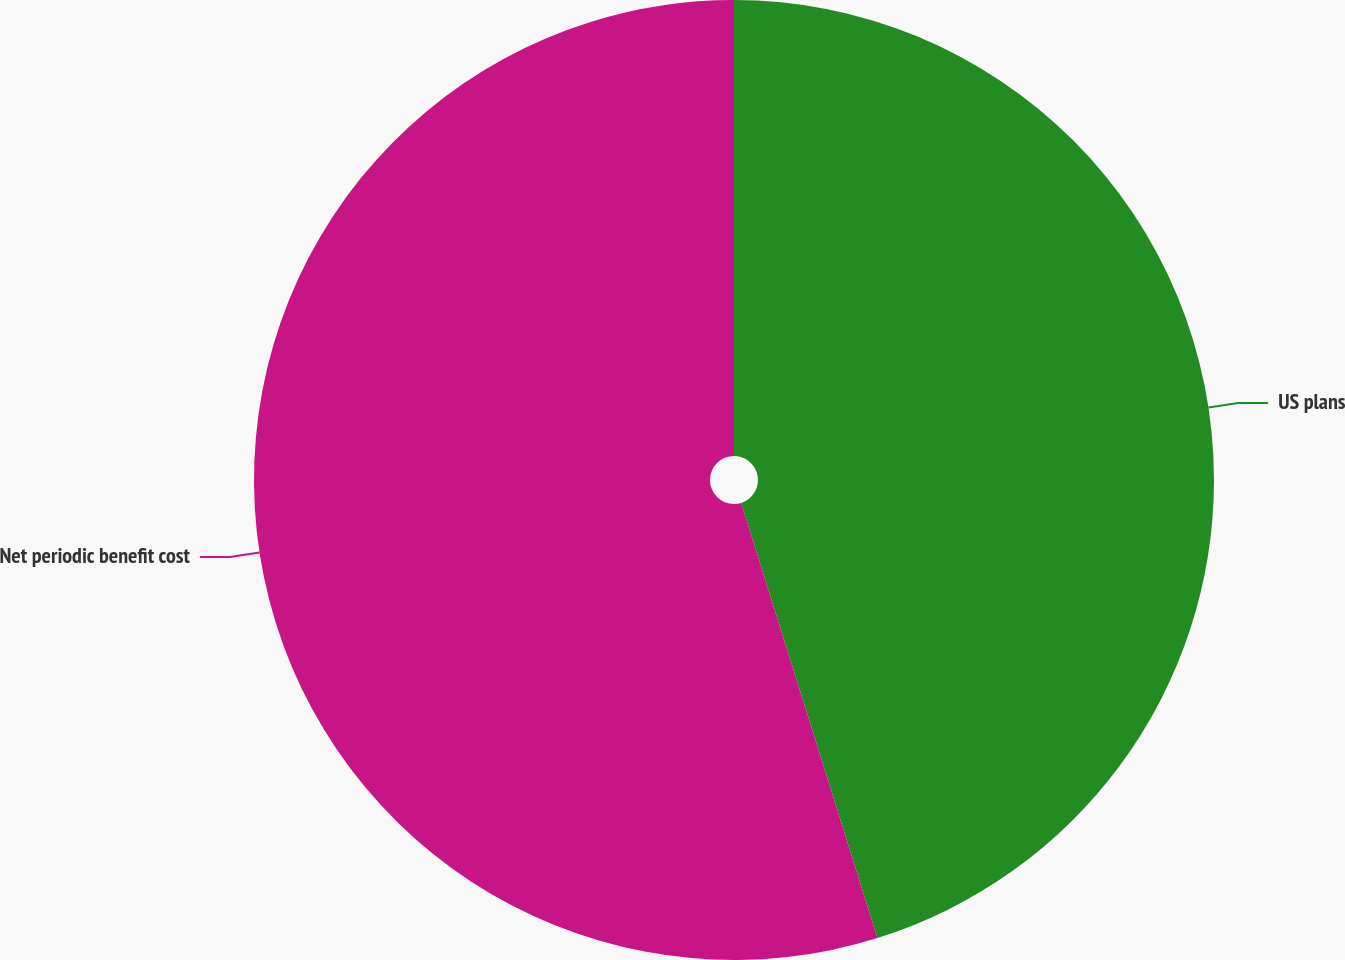Convert chart to OTSL. <chart><loc_0><loc_0><loc_500><loc_500><pie_chart><fcel>US plans<fcel>Net periodic benefit cost<nl><fcel>45.17%<fcel>54.83%<nl></chart> 